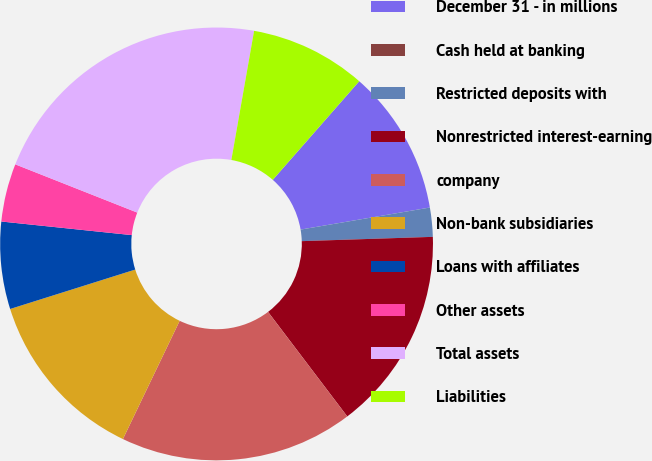<chart> <loc_0><loc_0><loc_500><loc_500><pie_chart><fcel>December 31 - in millions<fcel>Cash held at banking<fcel>Restricted deposits with<fcel>Nonrestricted interest-earning<fcel>company<fcel>Non-bank subsidiaries<fcel>Loans with affiliates<fcel>Other assets<fcel>Total assets<fcel>Liabilities<nl><fcel>10.85%<fcel>0.0%<fcel>2.17%<fcel>15.2%<fcel>17.44%<fcel>13.02%<fcel>6.51%<fcel>4.34%<fcel>21.78%<fcel>8.68%<nl></chart> 